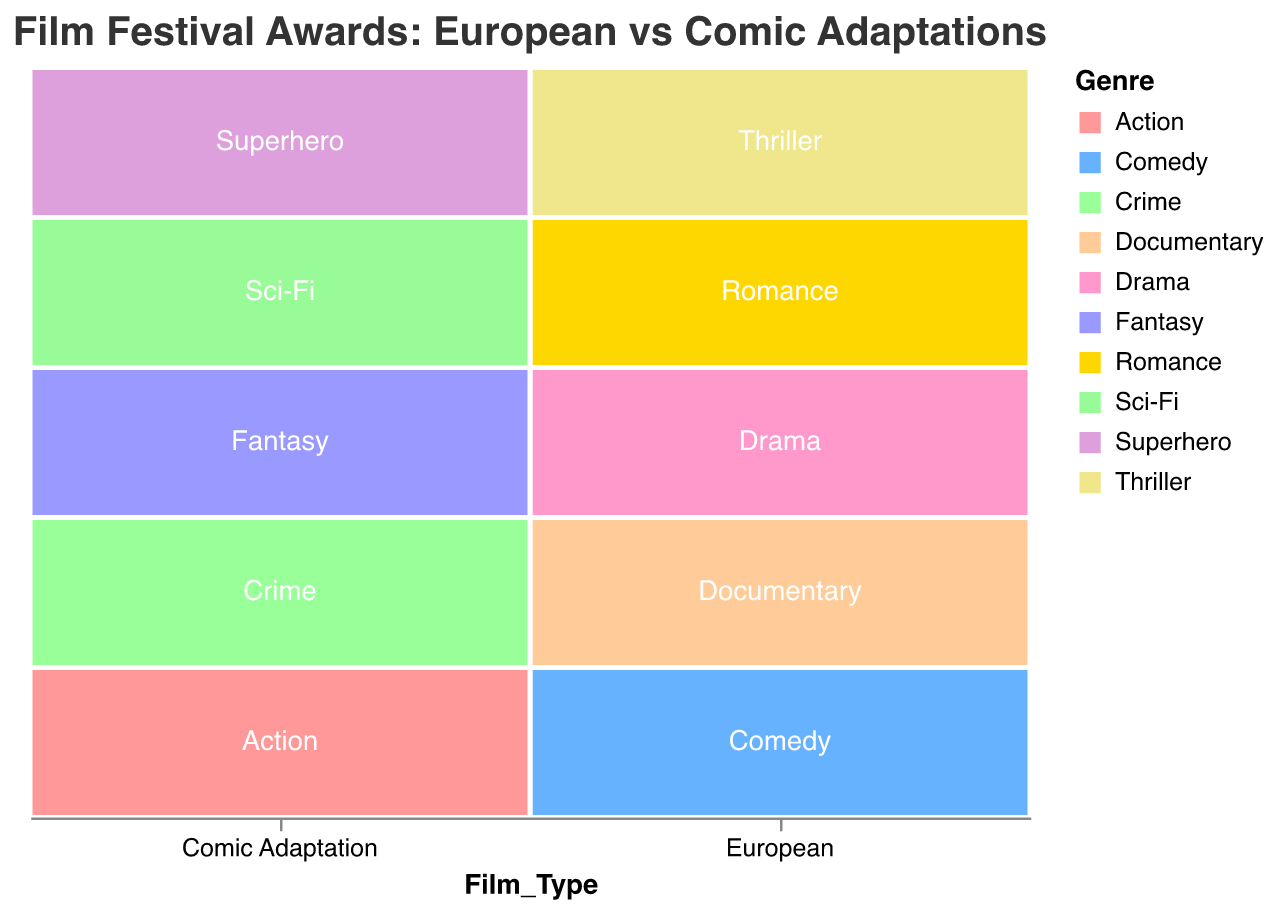Which film type has the highest number of awards in the Drama genre? According to the plot, the Drama genre's awards are visualized for only European films, with the total number of awards shown as 12.
Answer: European What is the combined number of awards for European Romance and Documentary genres? From the plot, the Romance genre has 6 awards and the Documentary genre has 5 awards for European films. The total is 6 + 5 = 11.
Answer: 11 Which genre got the fewest awards in comic book adaptations? The plot shows that the Fantasy genre for comic book adaptations received the fewest awards, with only 1 award.
Answer: Fantasy How do the number of awards for European Thrillers compare to Comic Adaptation Superhero genres? The plot shows European Thrillers have 10 awards, while Comic Adaptation Superhero genres have 4 awards. Hence, European Thrillers have more awards.
Answer: European Thrillers have more awards From which festival did European films receive awards in the Comedy genre? The plot indicates that European films in the Comedy genre received awards from the Berlin International Film Festival.
Answer: Berlin International Film Festival What is the total number of awards won by comic book adaptations across all festivals? From the plot, the awards for comic book adaptations (3+4+2+1+2) sum up to a total of 12 awards.
Answer: 12 In which genre and festival combination did European films receive the highest number of awards? The plot shows that European films received the highest number of awards (12) in the Drama genre at the Cannes Film Festival.
Answer: Drama at Cannes Film Festival Which film type dominates the Venice Film Festival in terms of awards? The plot shows that European films dominate the Venice Film Festival with Thriller genre awards totaling 10, compared to 2 for Comic Adaptations in the Sci-Fi genre.
Answer: European What is the difference in the number of awards between European and Comic Adaptation films at the Karlovy Vary International Film Festival? From the plot, European films received 6 awards (Romance) and Comic Adaptation films received 1 award (Fantasy) at the Karlovy Vary International Film Festival. The difference is 6 - 1 = 5.
Answer: 5 How many genres did European films win awards in, according to the plot? The plot indicates European films won awards in 5 different genres: Drama, Comedy, Thriller, Romance, and Documentary.
Answer: 5 genres 